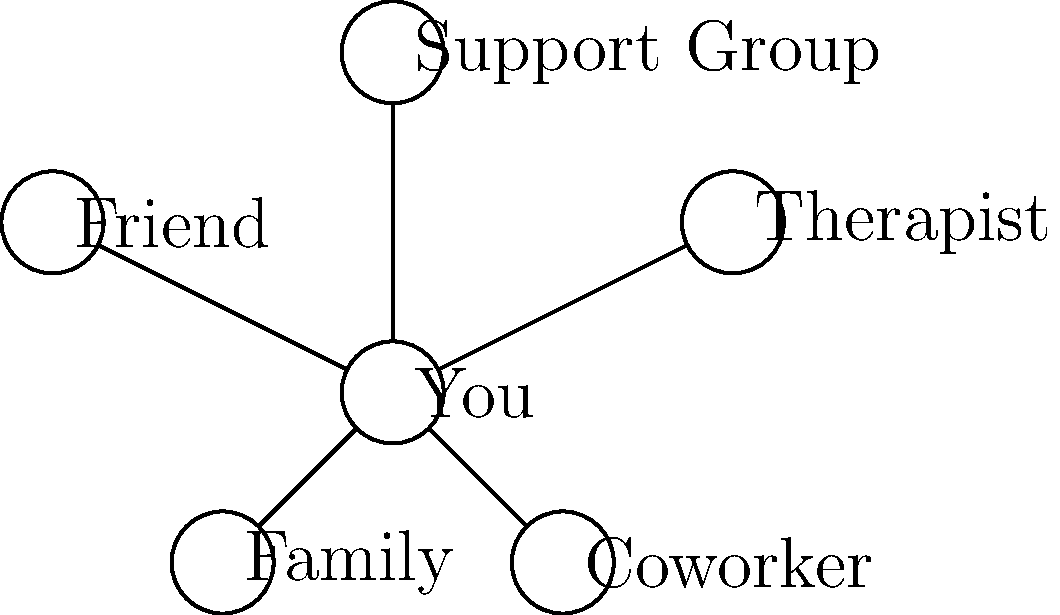In the social connections diagram above, which relationship is likely to provide the most professional and structured support for your trauma recovery process? To answer this question, we need to analyze the different relationships shown in the social connections diagram and consider their roles in trauma recovery:

1. You: This is the central node, representing the trauma survivor.

2. Therapist: This relationship is specifically designed to provide professional, structured support for mental health and trauma recovery.

3. Friend: While friends can offer emotional support, they typically lack professional training in trauma treatment.

4. Support Group: This can provide peer support and shared experiences, but may not offer individualized, professional treatment.

5. Family: Family members can offer emotional support, but may also be involved in or affected by the trauma, potentially complicating the recovery process.

6. Coworker: Coworkers generally provide limited personal support and are not typically involved in one's trauma recovery.

Among these relationships, the therapist stands out as the most likely to provide professional and structured support for trauma recovery. Therapists are trained professionals who specialize in mental health treatment, including trauma-specific interventions. They can offer evidence-based therapies, maintain professional boundaries, and provide a safe, confidential space for processing trauma.
Answer: Therapist 